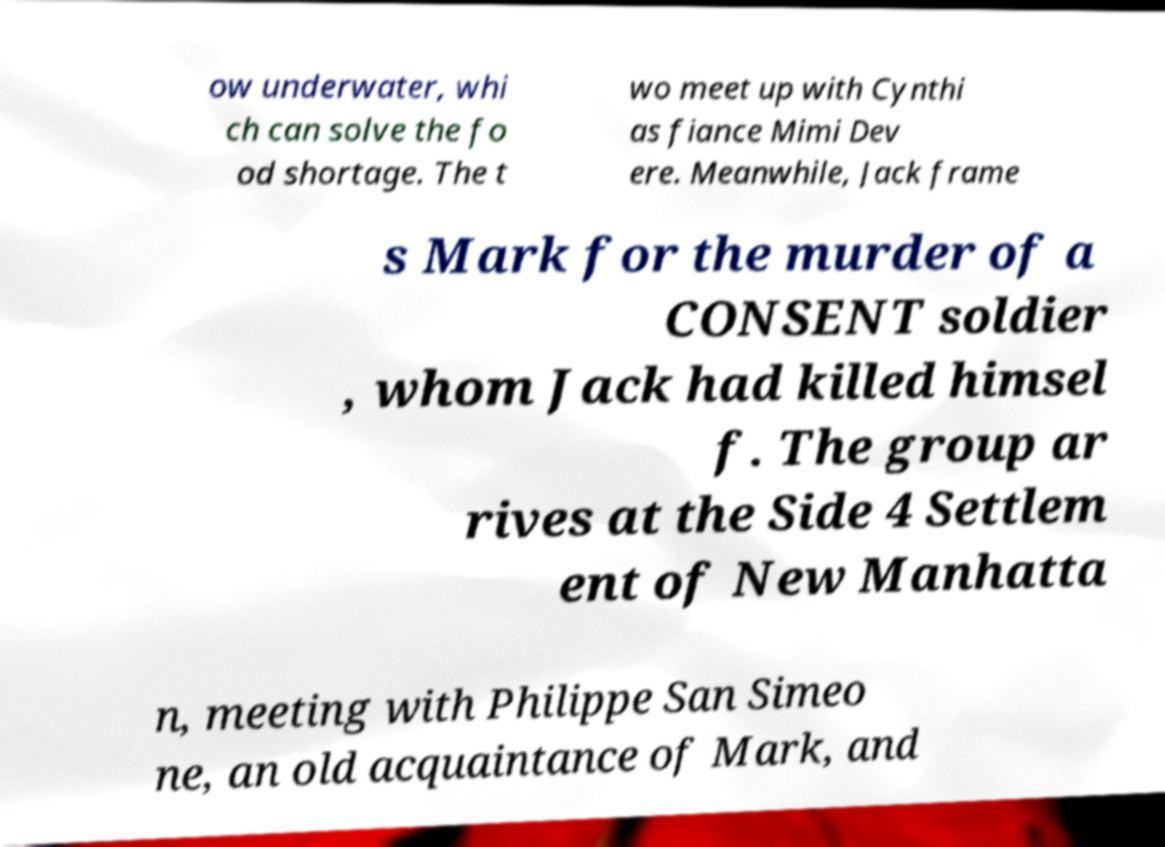Can you read and provide the text displayed in the image?This photo seems to have some interesting text. Can you extract and type it out for me? ow underwater, whi ch can solve the fo od shortage. The t wo meet up with Cynthi as fiance Mimi Dev ere. Meanwhile, Jack frame s Mark for the murder of a CONSENT soldier , whom Jack had killed himsel f. The group ar rives at the Side 4 Settlem ent of New Manhatta n, meeting with Philippe San Simeo ne, an old acquaintance of Mark, and 